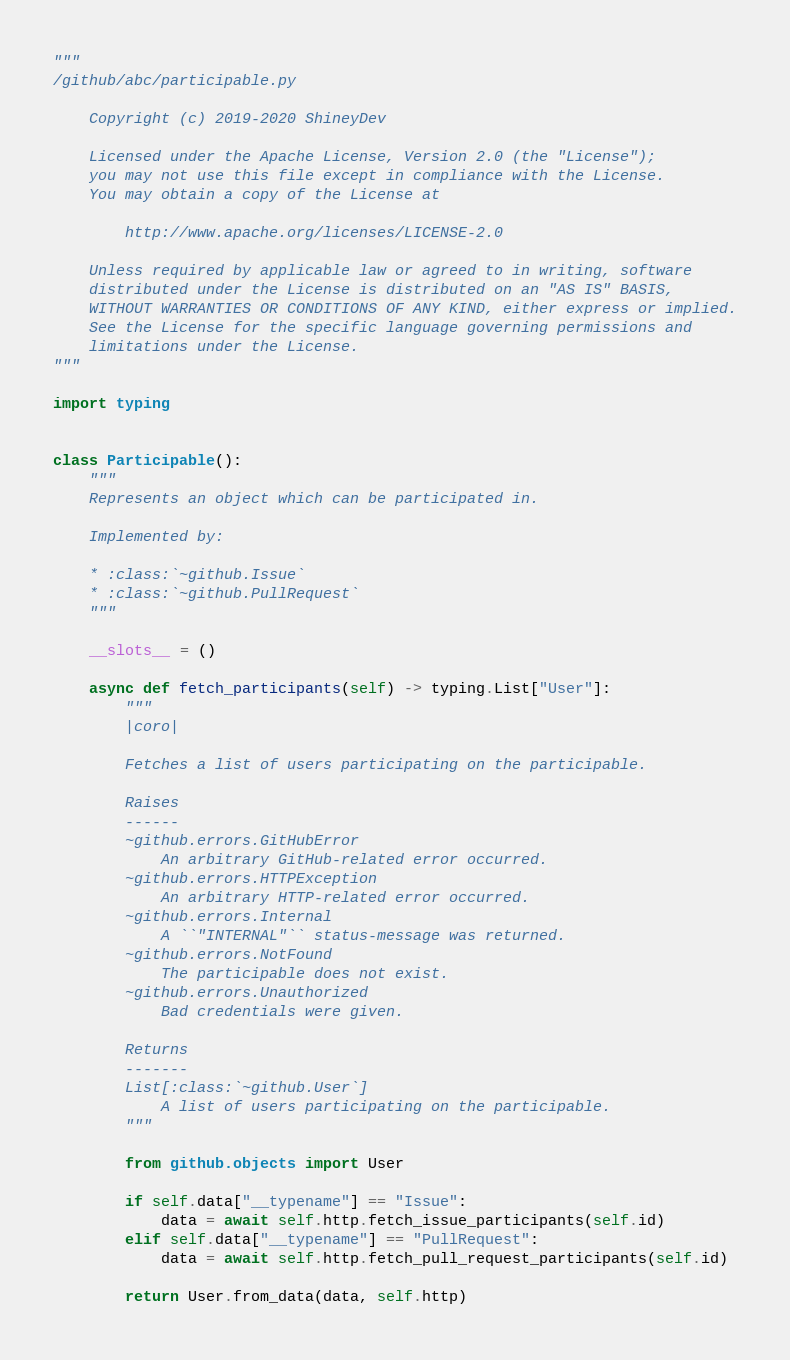Convert code to text. <code><loc_0><loc_0><loc_500><loc_500><_Python_>"""
/github/abc/participable.py

    Copyright (c) 2019-2020 ShineyDev
    
    Licensed under the Apache License, Version 2.0 (the "License");
    you may not use this file except in compliance with the License.
    You may obtain a copy of the License at

        http://www.apache.org/licenses/LICENSE-2.0

    Unless required by applicable law or agreed to in writing, software
    distributed under the License is distributed on an "AS IS" BASIS,
    WITHOUT WARRANTIES OR CONDITIONS OF ANY KIND, either express or implied.
    See the License for the specific language governing permissions and
    limitations under the License.
"""

import typing


class Participable():
    """
    Represents an object which can be participated in.

    Implemented by:

    * :class:`~github.Issue`
    * :class:`~github.PullRequest`
    """

    __slots__ = ()

    async def fetch_participants(self) -> typing.List["User"]:
        """
        |coro|

        Fetches a list of users participating on the participable.

        Raises
        ------
        ~github.errors.GitHubError
            An arbitrary GitHub-related error occurred.
        ~github.errors.HTTPException
            An arbitrary HTTP-related error occurred.
        ~github.errors.Internal
            A ``"INTERNAL"`` status-message was returned.
        ~github.errors.NotFound
            The participable does not exist.
        ~github.errors.Unauthorized
            Bad credentials were given.

        Returns
        -------
        List[:class:`~github.User`]
            A list of users participating on the participable.
        """

        from github.objects import User

        if self.data["__typename"] == "Issue":
            data = await self.http.fetch_issue_participants(self.id)
        elif self.data["__typename"] == "PullRequest":
            data = await self.http.fetch_pull_request_participants(self.id)

        return User.from_data(data, self.http)
</code> 